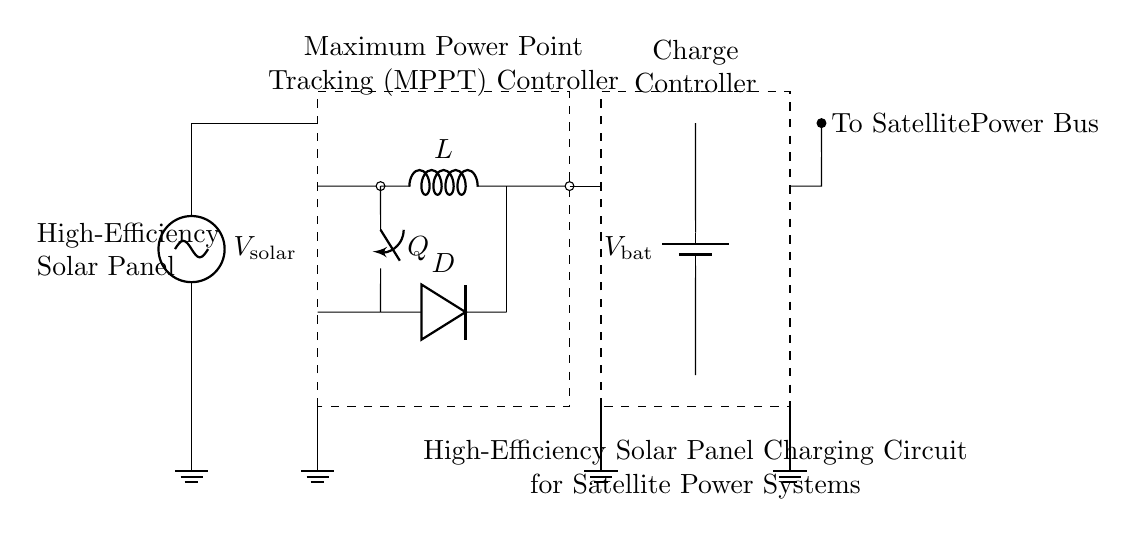What is the type of solar energy source used in this circuit? The circuit diagram indicates the use of a solar panel as the energy source, clearly labeled at the top of the circuit.
Answer: solar panel What component regulates the power output from the solar panel? The circuit shows a Maximum Power Point Tracking (MPPT) Controller, which adjusts the output to optimize power extraction from the solar panel.
Answer: MPPT Controller What is the role of the buck converter in this circuit? The buck converter, located inside the MPPT section, steps down the voltage from the solar panel to match the charging requirements of the battery.
Answer: Step down voltage How many main components are shown in the circuit? The main components include a solar panel, MPPT controller with a buck converter, battery, and charge controller, totaling four main components connected in series.
Answer: four What type of diode is used in the buck converter circuit? The diagram specifies a diode labeled as D, which is characteristic of a buck converter circuit to allow current to flow in one direction during the switching process.
Answer: diode What is the voltage source of the battery represented in the diagram? The battery is labeled with the voltage symbol V_bat, signifying it serves as the power storage component in the circuit providing energy to the satellite power bus.
Answer: V_bat What is the output direction of the circuit to the satellite power bus? The output from the circuit to the satellite power bus is illustrated with a line leading from the charge controller to the bus, indicating the direction of the electrical flow.
Answer: To Satellite Power Bus 